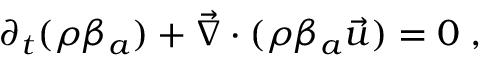<formula> <loc_0><loc_0><loc_500><loc_500>\partial _ { t } ( \rho \beta _ { a } ) + \vec { \nabla } \cdot ( \rho \beta _ { a } \vec { u } ) = 0 \, ,</formula> 